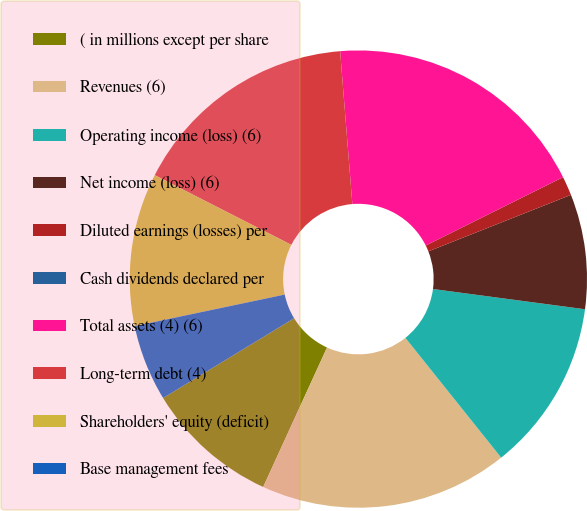Convert chart to OTSL. <chart><loc_0><loc_0><loc_500><loc_500><pie_chart><fcel>( in millions except per share<fcel>Revenues (6)<fcel>Operating income (loss) (6)<fcel>Net income (loss) (6)<fcel>Diluted earnings (losses) per<fcel>Cash dividends declared per<fcel>Total assets (4) (6)<fcel>Long-term debt (4)<fcel>Shareholders' equity (deficit)<fcel>Base management fees<nl><fcel>9.46%<fcel>17.57%<fcel>12.16%<fcel>8.11%<fcel>1.35%<fcel>0.0%<fcel>18.92%<fcel>16.22%<fcel>10.81%<fcel>5.41%<nl></chart> 